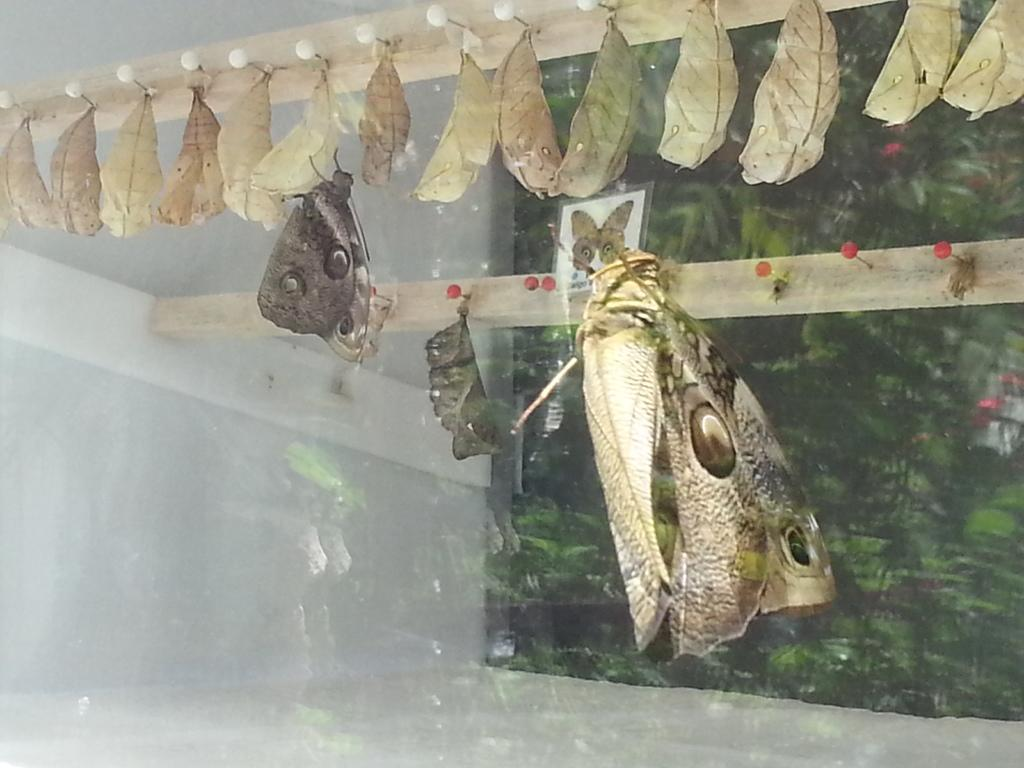How many butterflies can be seen in the image? There are two butterflies in the image. What is hanging from the hangers in the image? Dried leaves are hanging from the hangers in the image. What type of watercraft is present in the image? There is a small boat in the image. What type of door is visible in the image? There is a glass door in the image. What type of vegetation is visible in the image? Trees are visible in the image. Can you read the note that the girl is holding in the image? There is no girl present in the image, and therefore no note to read. How many bubbles are floating around the butterflies in the image? There are no bubbles present in the image; only butterflies, dried leaves, a small boat, a glass door, and trees are visible. 